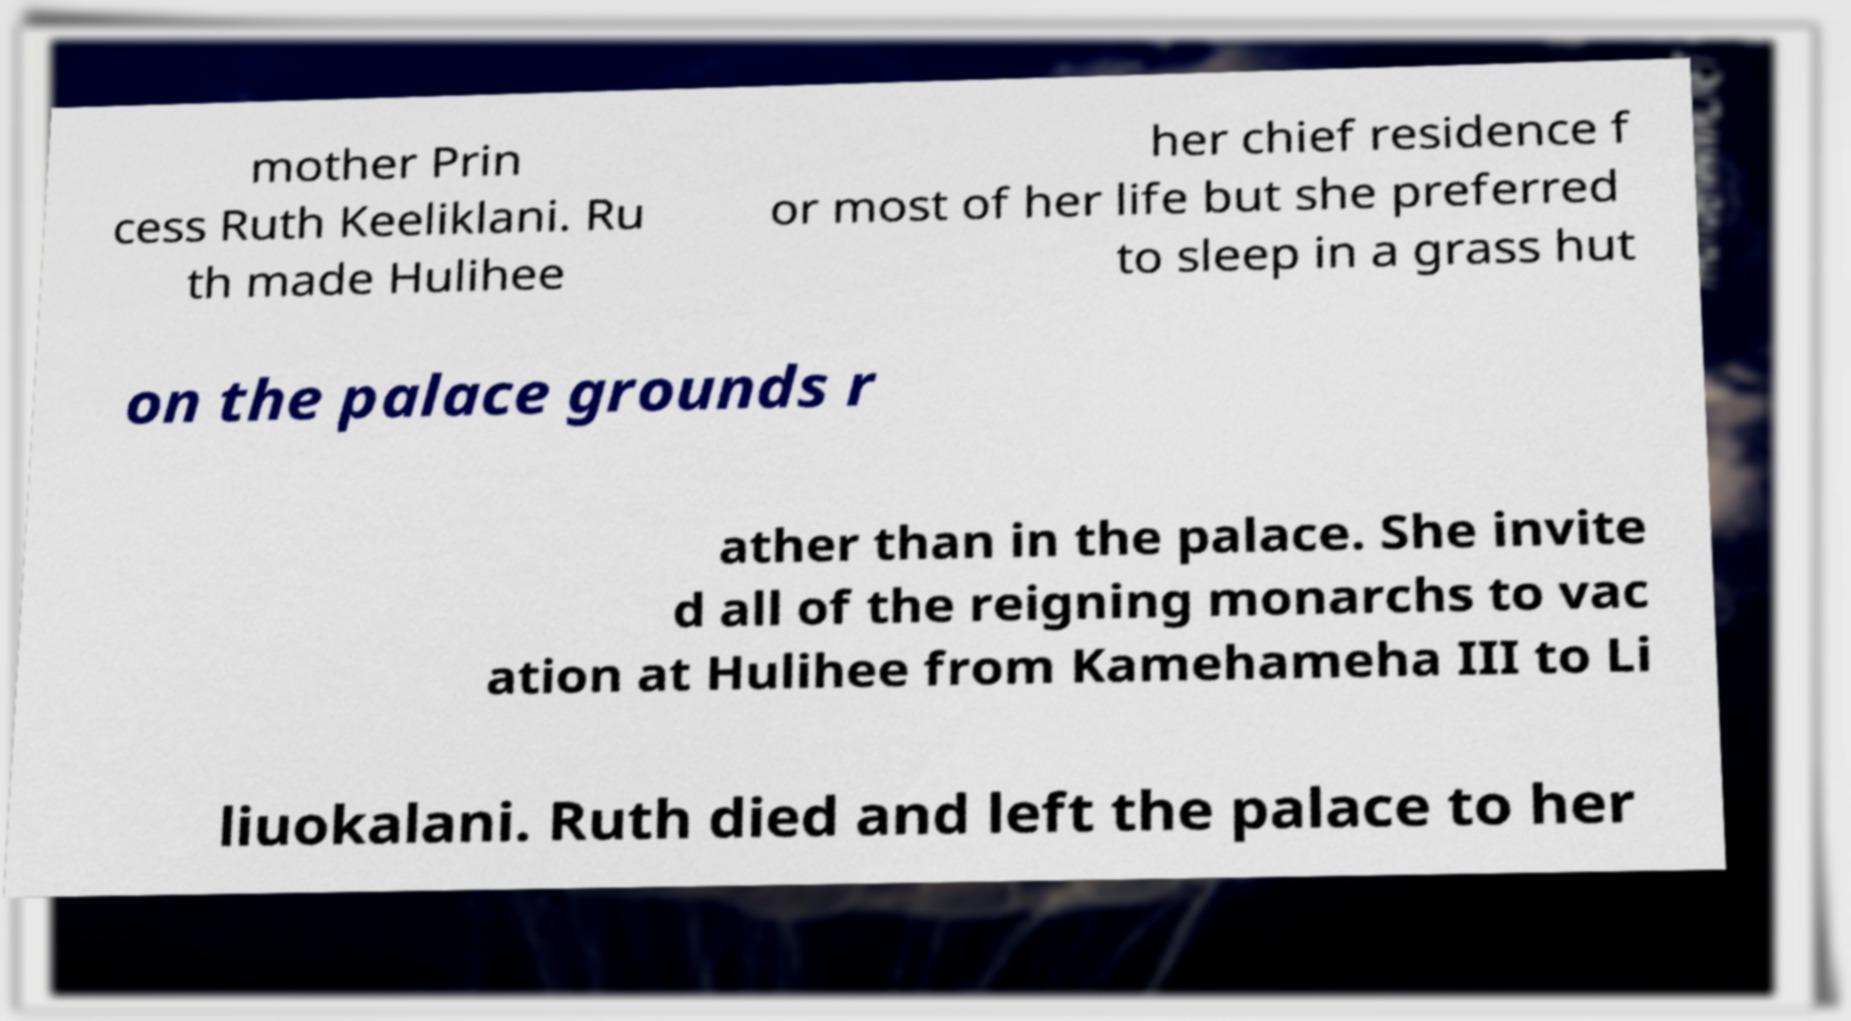What messages or text are displayed in this image? I need them in a readable, typed format. mother Prin cess Ruth Keeliklani. Ru th made Hulihee her chief residence f or most of her life but she preferred to sleep in a grass hut on the palace grounds r ather than in the palace. She invite d all of the reigning monarchs to vac ation at Hulihee from Kamehameha III to Li liuokalani. Ruth died and left the palace to her 